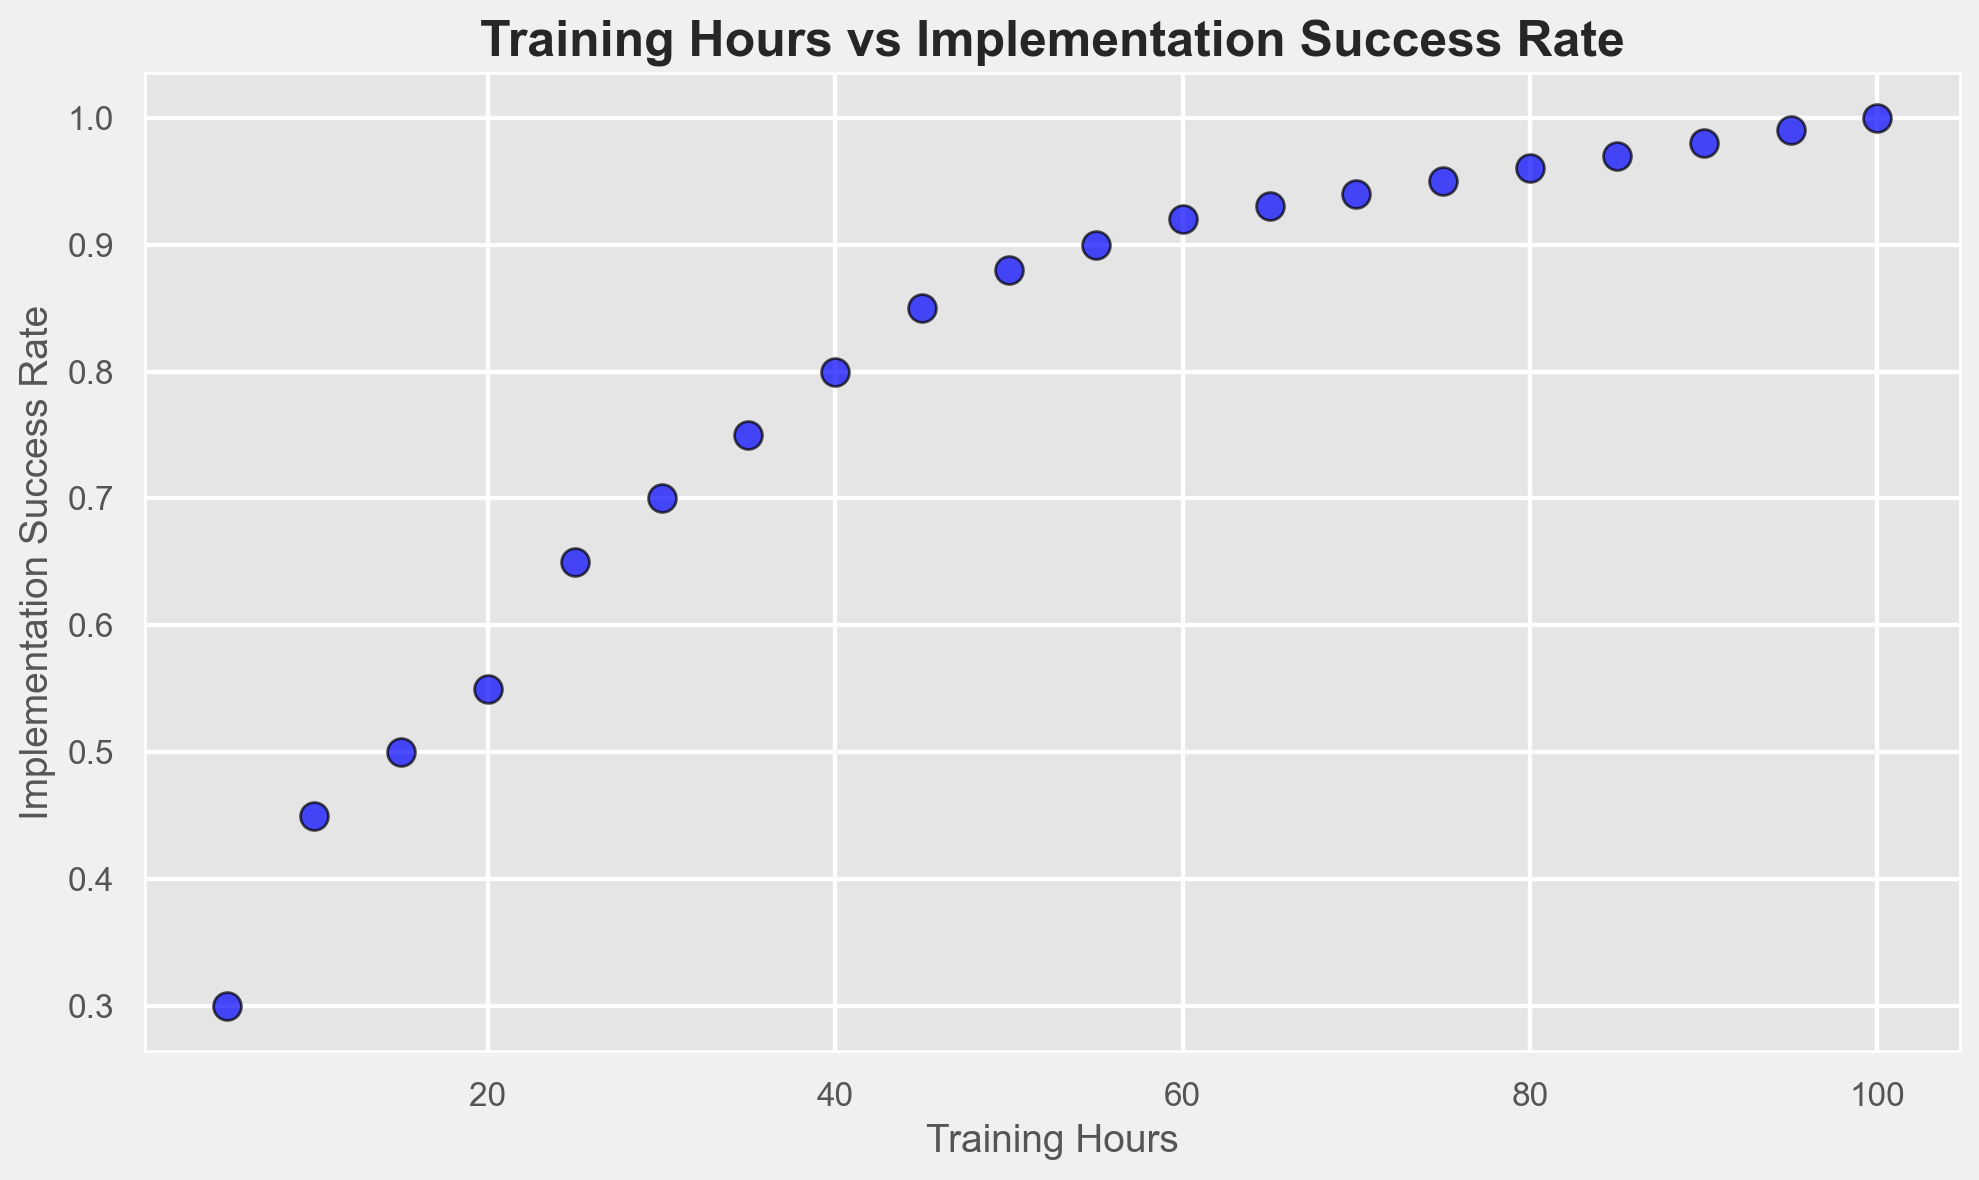What is the implementation success rate at 50 training hours? The figure shows various points representing the training hours and their corresponding implementation success rates. Looking at the plot for when training hours equal 50, the corresponding success rate is clearly displayed.
Answer: 0.88 At which training hour mark does the implementation success rate reach 0.9? By examining the scatter plot, we can locate the point where the success rate reaches 0.9 and identify the corresponding training hours for that data point.
Answer: 55 How much higher is the implementation success rate at 70 training hours compared to 30 training hours? The plot shows the implementation success rate for each training hour mark; at 70 training hours, the rate is 0.94 and at 30 training hours it is 0.7. Calculating the difference: 0.94 - 0.7 gives the answer.
Answer: 0.24 What is the overall trend between training hours and implementation success rate? Observing the scatter plot, it is clear that as training hours increase, the implementation success rate also increases, indicating a positive correlation between the two variables.
Answer: Positive correlation Is there a noticeable change in the implementation success rate beyond 80 training hours? By looking at the scatter plot, we observe the rate from 80 hours (0.96) to 100 hours (1.0). The success rate increases but at a smaller increment compared to initial hours, indicating a slight plateau.
Answer: Slight plateau How many data points have an implementation success rate of at least 0.9? By counting the points on the scatter plot with an implementation success rate of 0.9 or higher, we can determine the number of such data points, starting from 55 training hours onward.
Answer: 11 How does the implementation success rate change from 15 to 65 training hours? By observing the plot, at 15 training hours, the rate is 0.5, and at 65 training hours, it is 0.93. To find the change, subtract the smaller value from the larger one: 0.93 - 0.5.
Answer: 0.43 